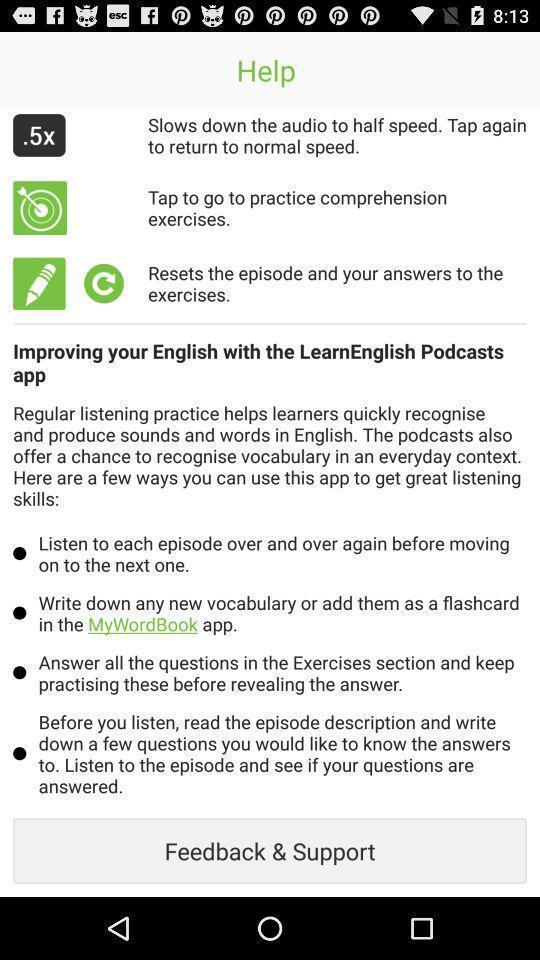What details can you identify in this image? Screen displaying help page for an app. 